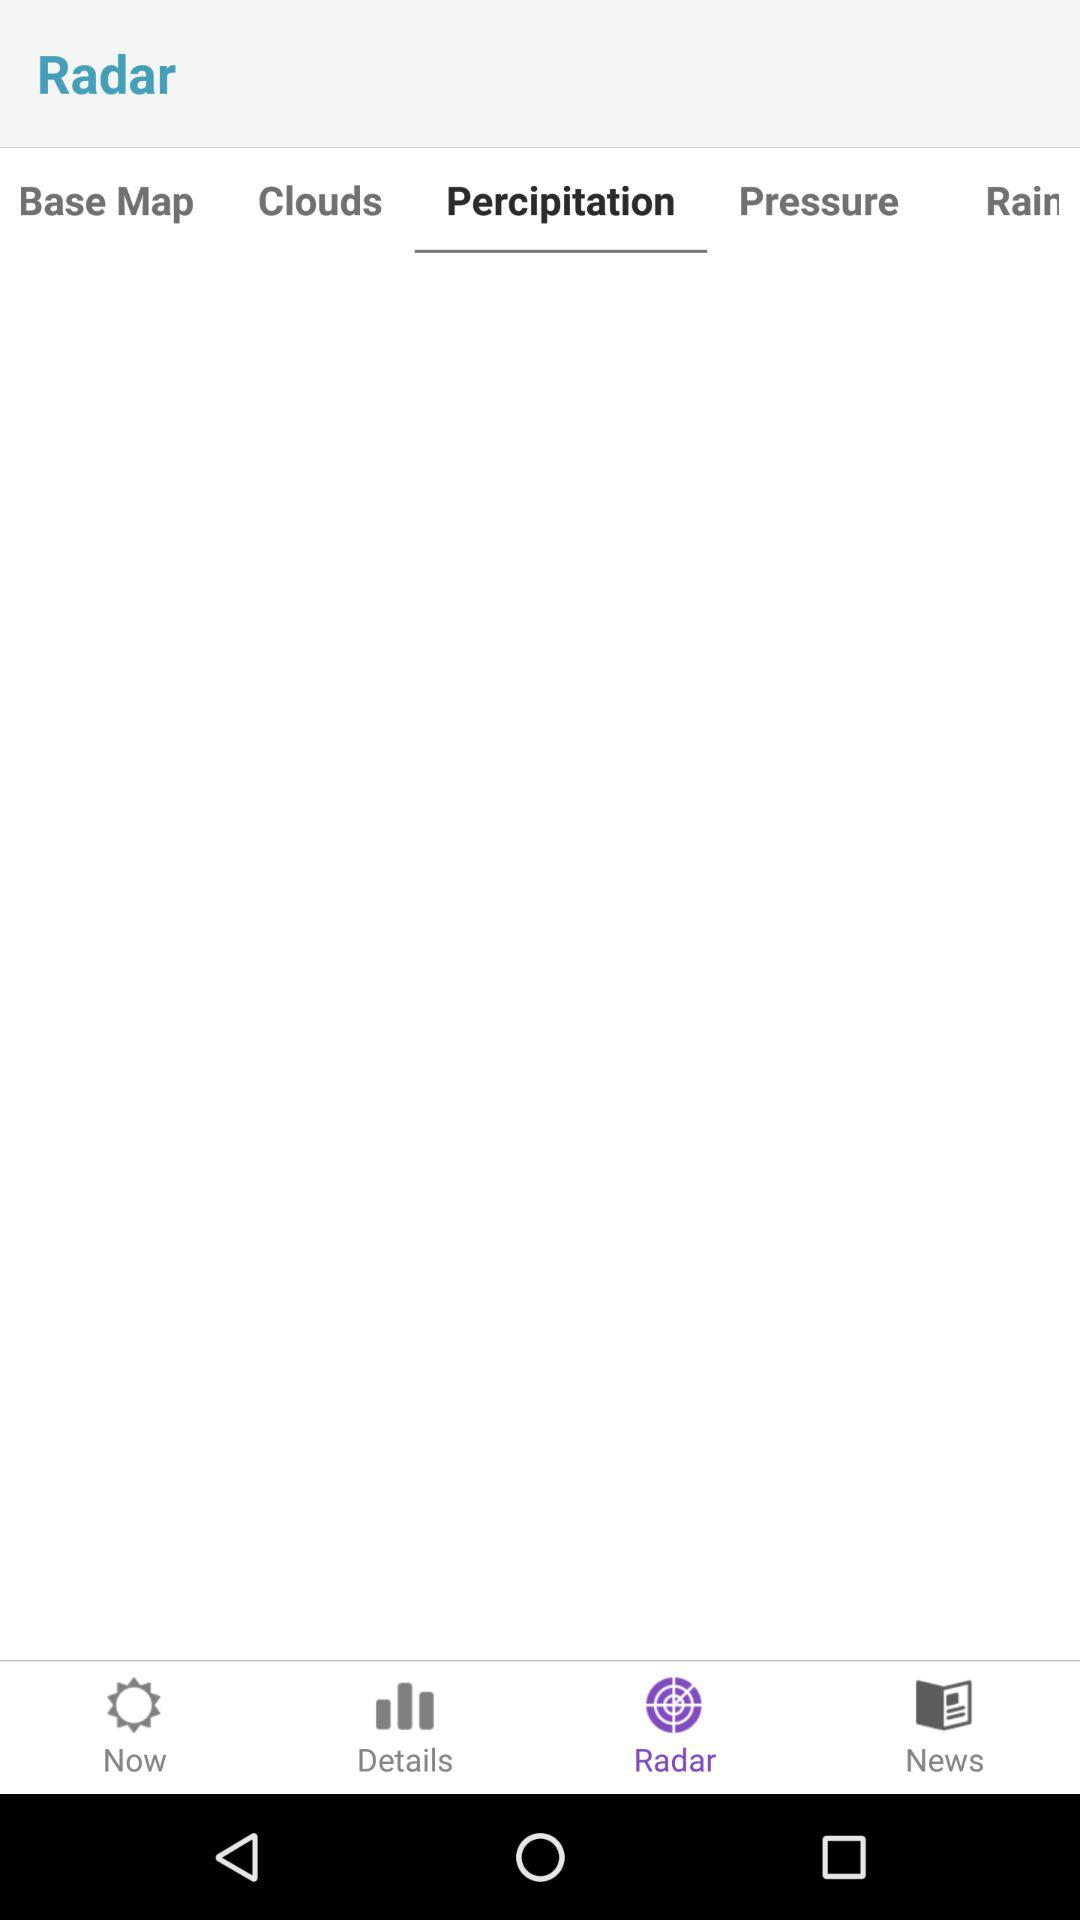Which tab is selected? The selected tabs are "Radar" and "Percipitation". 